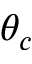Convert formula to latex. <formula><loc_0><loc_0><loc_500><loc_500>\theta _ { c }</formula> 